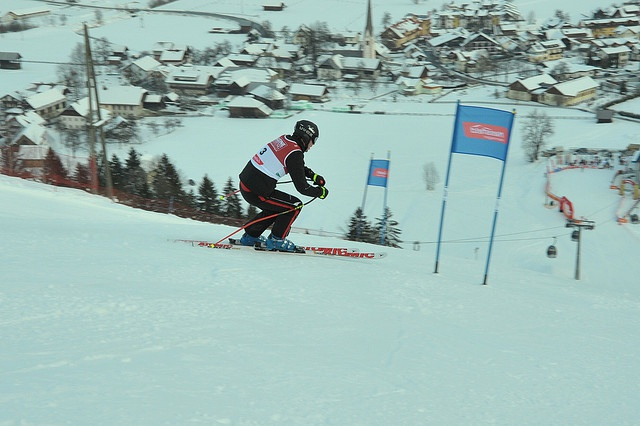Describe the objects in this image and their specific colors. I can see people in lightblue, black, and gray tones and skis in lightblue, darkgray, and brown tones in this image. 